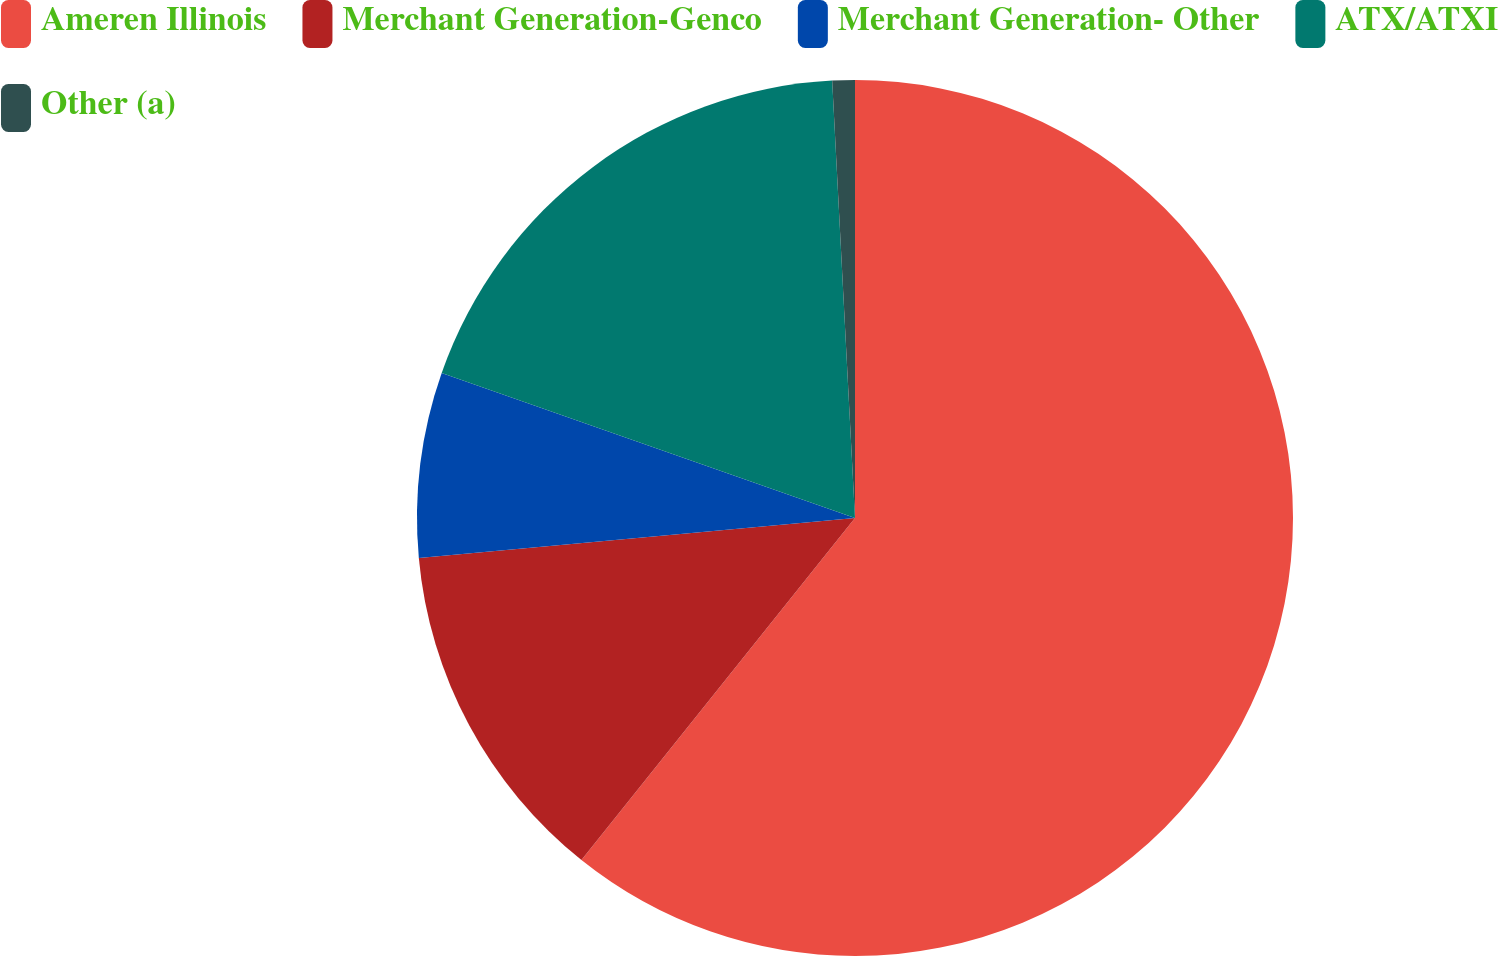Convert chart. <chart><loc_0><loc_0><loc_500><loc_500><pie_chart><fcel>Ameren Illinois<fcel>Merchant Generation-Genco<fcel>Merchant Generation- Other<fcel>ATX/ATXI<fcel>Other (a)<nl><fcel>60.73%<fcel>12.81%<fcel>6.82%<fcel>18.8%<fcel>0.83%<nl></chart> 